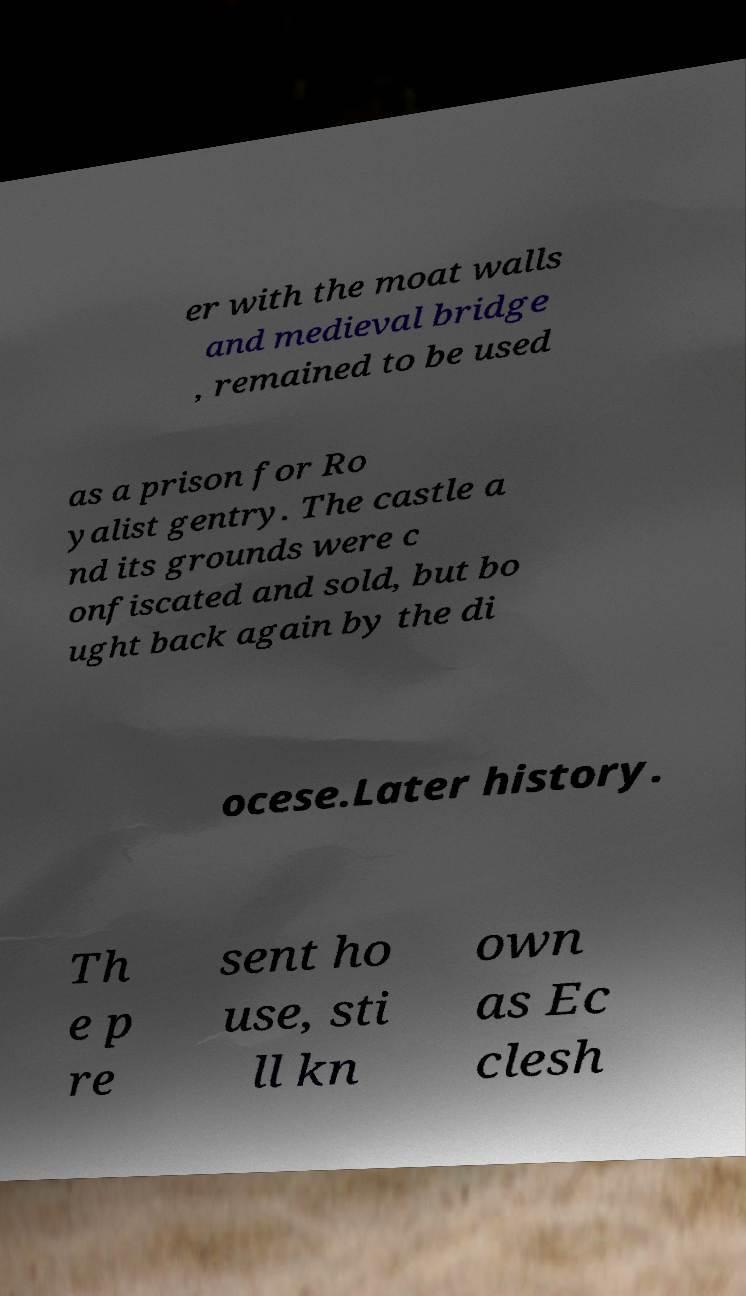Can you read and provide the text displayed in the image?This photo seems to have some interesting text. Can you extract and type it out for me? er with the moat walls and medieval bridge , remained to be used as a prison for Ro yalist gentry. The castle a nd its grounds were c onfiscated and sold, but bo ught back again by the di ocese.Later history. Th e p re sent ho use, sti ll kn own as Ec clesh 